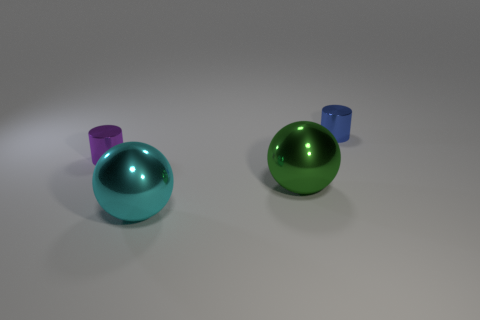Add 2 big yellow metal blocks. How many objects exist? 6 Add 3 purple cylinders. How many purple cylinders are left? 4 Add 4 cyan metal balls. How many cyan metal balls exist? 5 Subtract 0 yellow blocks. How many objects are left? 4 Subtract all large brown spheres. Subtract all big cyan spheres. How many objects are left? 3 